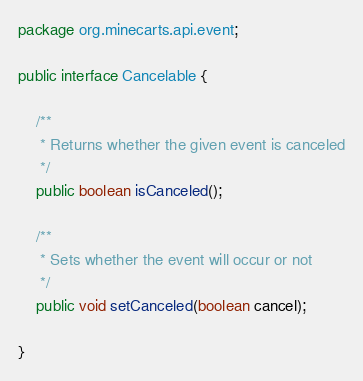<code> <loc_0><loc_0><loc_500><loc_500><_Java_>package org.minecarts.api.event;

public interface Cancelable {

    /**
     * Returns whether the given event is canceled
     */
    public boolean isCanceled();

    /**
     * Sets whether the event will occur or not
     */
    public void setCanceled(boolean cancel);

}</code> 